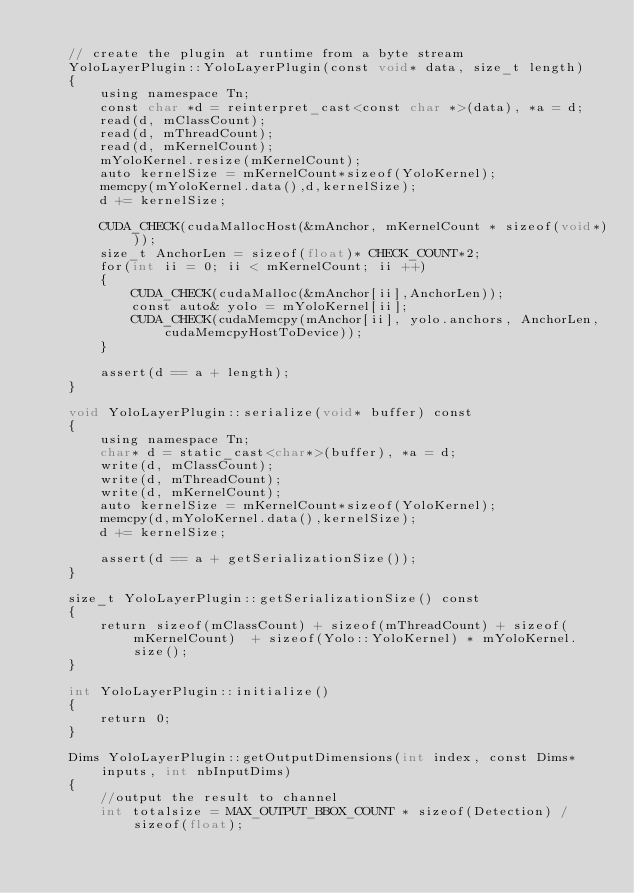Convert code to text. <code><loc_0><loc_0><loc_500><loc_500><_Cuda_>
    // create the plugin at runtime from a byte stream
    YoloLayerPlugin::YoloLayerPlugin(const void* data, size_t length)
    {
        using namespace Tn;
        const char *d = reinterpret_cast<const char *>(data), *a = d;
        read(d, mClassCount);
        read(d, mThreadCount);
        read(d, mKernelCount);
        mYoloKernel.resize(mKernelCount);
        auto kernelSize = mKernelCount*sizeof(YoloKernel);
        memcpy(mYoloKernel.data(),d,kernelSize);
        d += kernelSize;

        CUDA_CHECK(cudaMallocHost(&mAnchor, mKernelCount * sizeof(void*)));
        size_t AnchorLen = sizeof(float)* CHECK_COUNT*2;
        for(int ii = 0; ii < mKernelCount; ii ++)
        {
            CUDA_CHECK(cudaMalloc(&mAnchor[ii],AnchorLen));
            const auto& yolo = mYoloKernel[ii];
            CUDA_CHECK(cudaMemcpy(mAnchor[ii], yolo.anchors, AnchorLen, cudaMemcpyHostToDevice));
        }

        assert(d == a + length);
    }

    void YoloLayerPlugin::serialize(void* buffer) const
    {
        using namespace Tn;
        char* d = static_cast<char*>(buffer), *a = d;
        write(d, mClassCount);
        write(d, mThreadCount);
        write(d, mKernelCount);
        auto kernelSize = mKernelCount*sizeof(YoloKernel);
        memcpy(d,mYoloKernel.data(),kernelSize);
        d += kernelSize;

        assert(d == a + getSerializationSize());
    }
    
    size_t YoloLayerPlugin::getSerializationSize() const
    {  
        return sizeof(mClassCount) + sizeof(mThreadCount) + sizeof(mKernelCount)  + sizeof(Yolo::YoloKernel) * mYoloKernel.size();
    }

    int YoloLayerPlugin::initialize()
    { 
        return 0;
    }
    
    Dims YoloLayerPlugin::getOutputDimensions(int index, const Dims* inputs, int nbInputDims)
    {
        //output the result to channel
        int totalsize = MAX_OUTPUT_BBOX_COUNT * sizeof(Detection) / sizeof(float);
</code> 